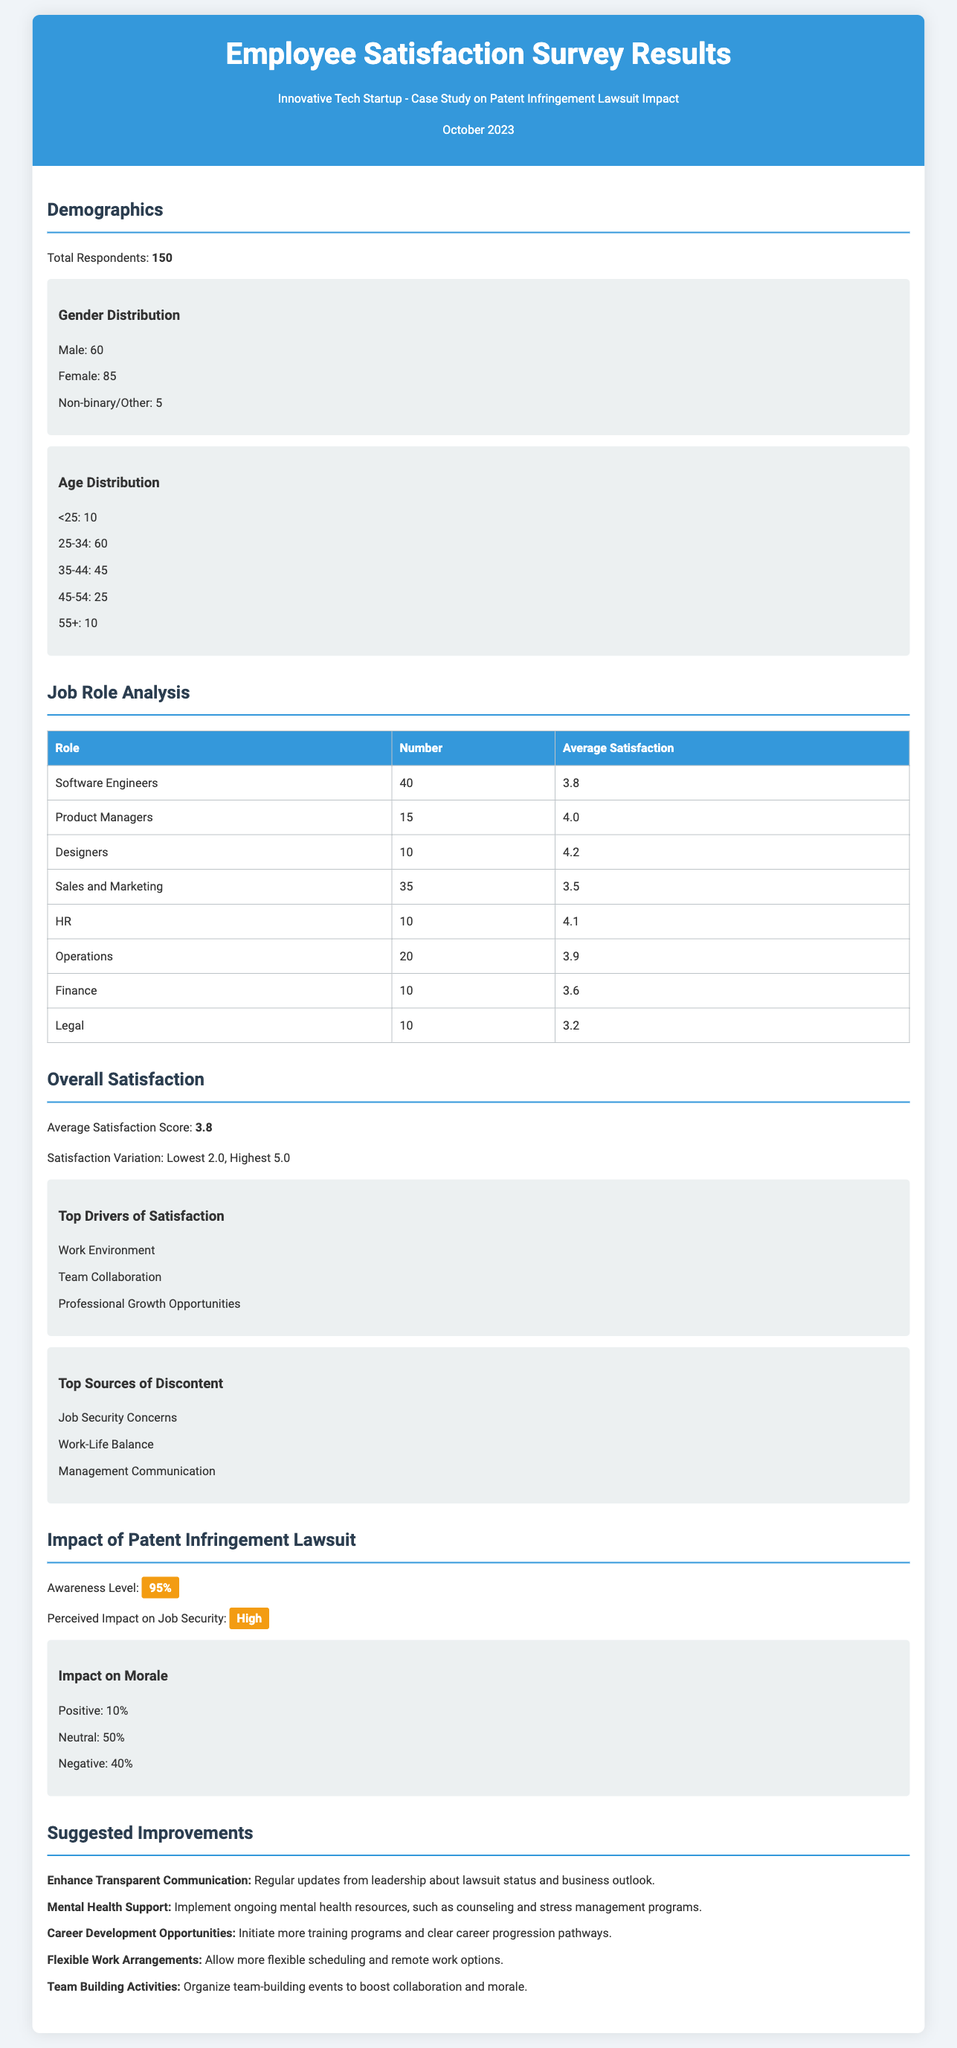What is the total number of respondents? The total number of respondents is stated in the Demographics section as 150.
Answer: 150 How many female respondents were there? The number of female respondents is listed in the Gender Distribution part, which states 85.
Answer: 85 What is the average satisfaction score? The average satisfaction score is mentioned in the Overall Satisfaction section as 3.8.
Answer: 3.8 Which job role has the highest average satisfaction? The job role analysis table shows Designers with an average satisfaction of 4.2, which is the highest.
Answer: Designers What percentage of respondents felt a negative impact on morale due to the lawsuit? The impact on morale section states that 40% of respondents felt a negative impact.
Answer: 40% What is the suggested improvement related to mental health? The suggested improvement mentions implementing ongoing mental health resources, such as counseling.
Answer: Mental Health Support How many Software Engineers participated in the survey? The Job Role Analysis table shows that there were 40 Software Engineers among the respondents.
Answer: 40 What is the awareness level regarding the patent infringement lawsuit? The document states the awareness level as 95% in the Impact of Patent Infringement Lawsuit section.
Answer: 95% What is one of the top sources of discontent mentioned? The section on Top Sources of Discontent specifically lists Job Security Concerns as one of the issues.
Answer: Job Security Concerns 